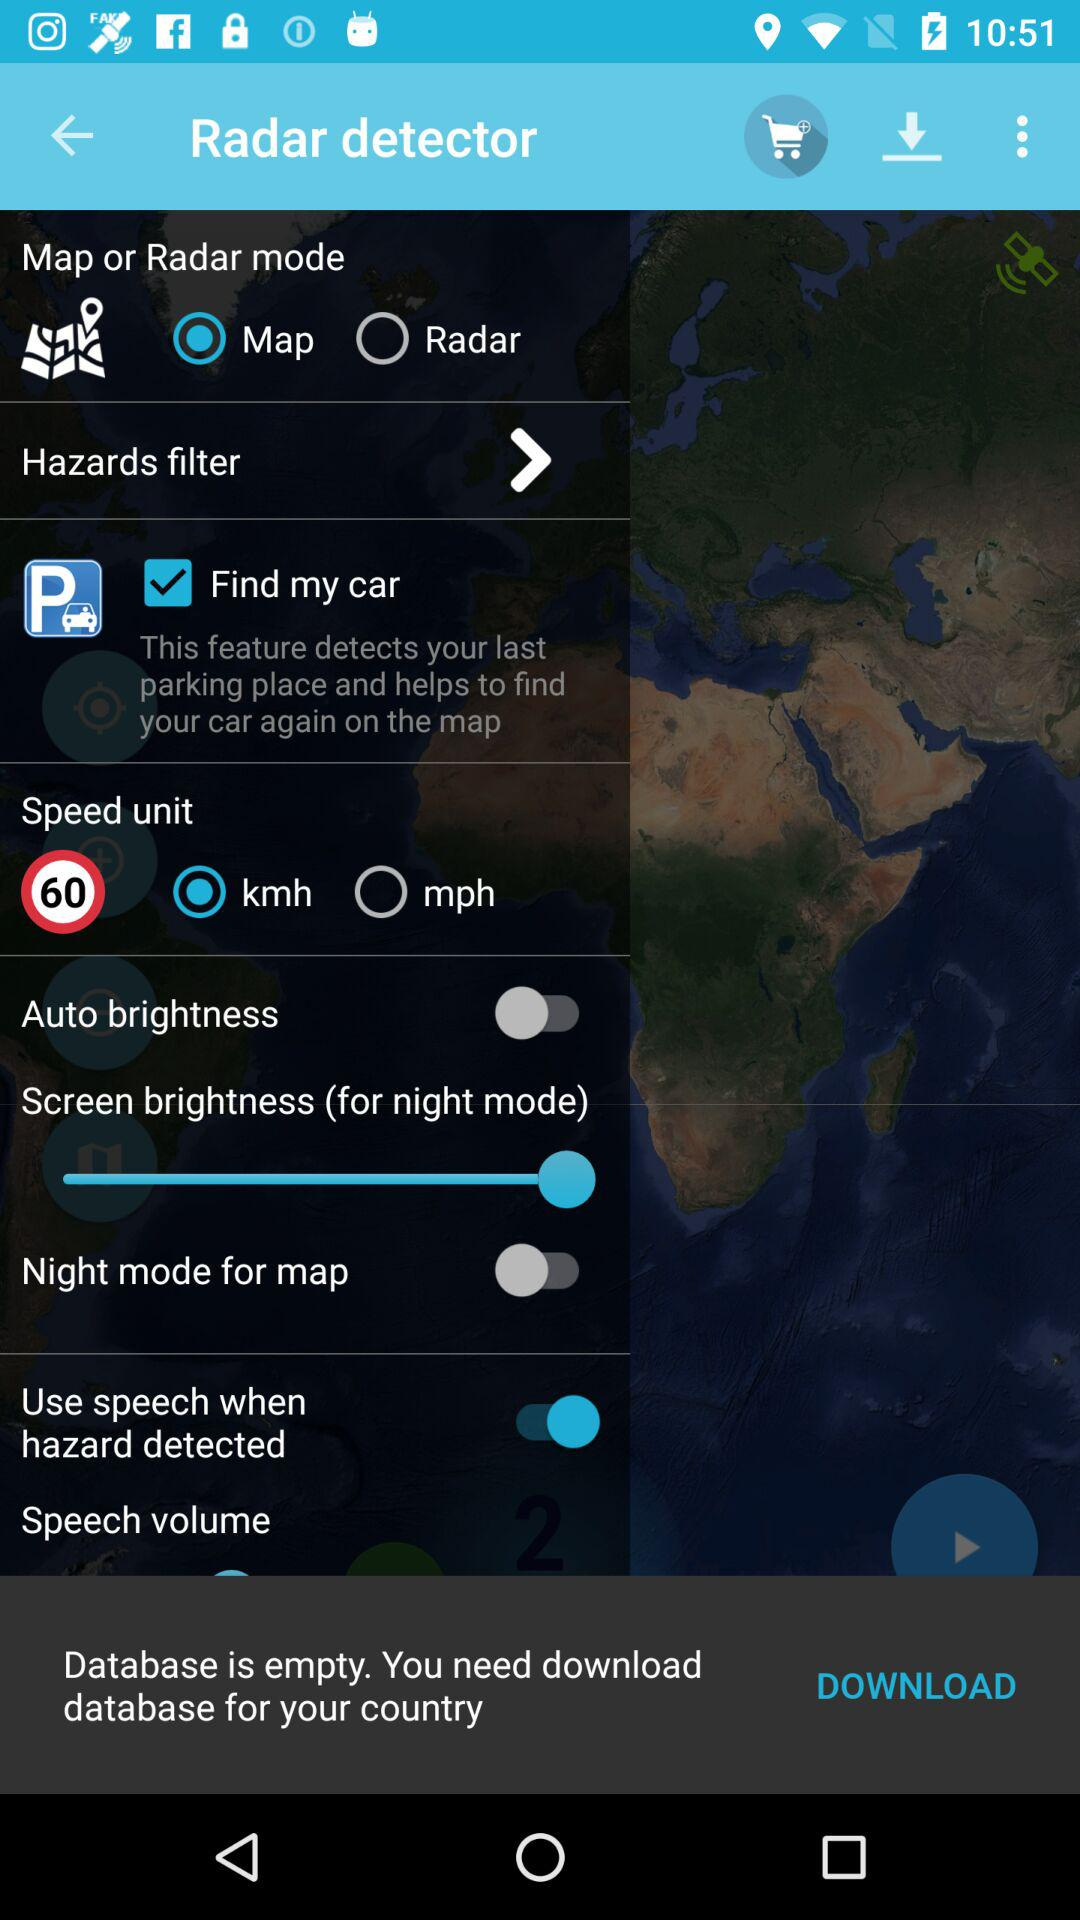What is the status of "Auto brightness"? The status of "Auto brightness" is "off". 